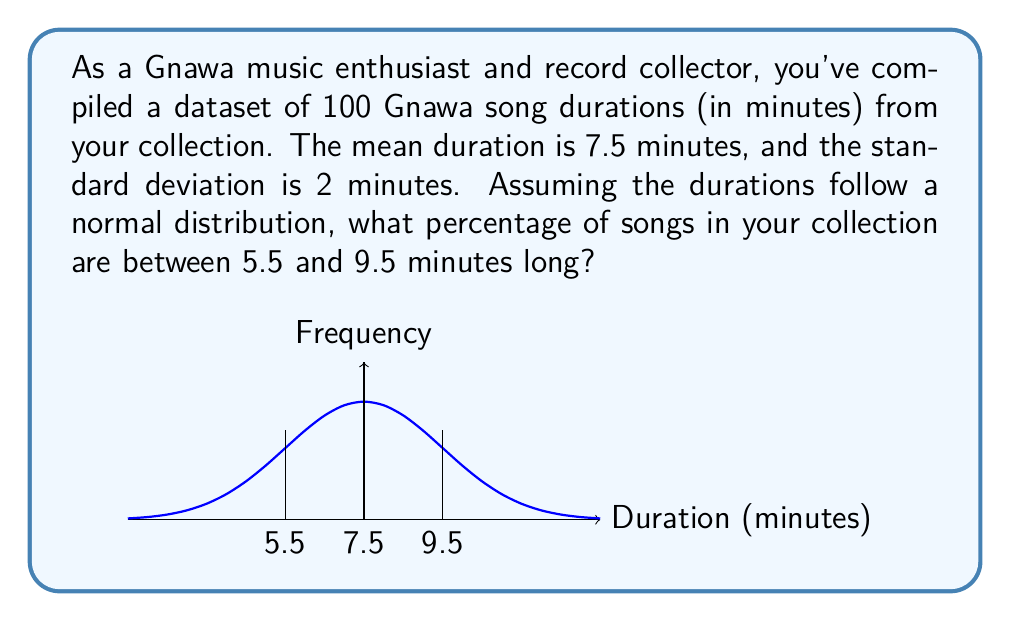Provide a solution to this math problem. Let's approach this step-by-step:

1) We're given that the song durations follow a normal distribution with:
   Mean (μ) = 7.5 minutes
   Standard deviation (σ) = 2 minutes

2) We want to find the probability that a song duration (X) is between 5.5 and 9.5 minutes.
   P(5.5 < X < 9.5)

3) To use the standard normal distribution, we need to standardize these values:
   Z = (X - μ) / σ

   For X = 5.5: Z1 = (5.5 - 7.5) / 2 = -1
   For X = 9.5: Z2 = (9.5 - 7.5) / 2 = 1

4) Now we're looking for: P(-1 < Z < 1)

5) Using the standard normal distribution table or calculator:
   P(Z < 1) = 0.8413
   P(Z < -1) = 0.1587

6) The probability we're looking for is:
   P(-1 < Z < 1) = P(Z < 1) - P(Z < -1)
                 = 0.8413 - 0.1587
                 = 0.6826

7) Convert to percentage:
   0.6826 * 100 = 68.26%

Therefore, approximately 68.26% of the songs in your collection are between 5.5 and 9.5 minutes long.
Answer: 68.26% 